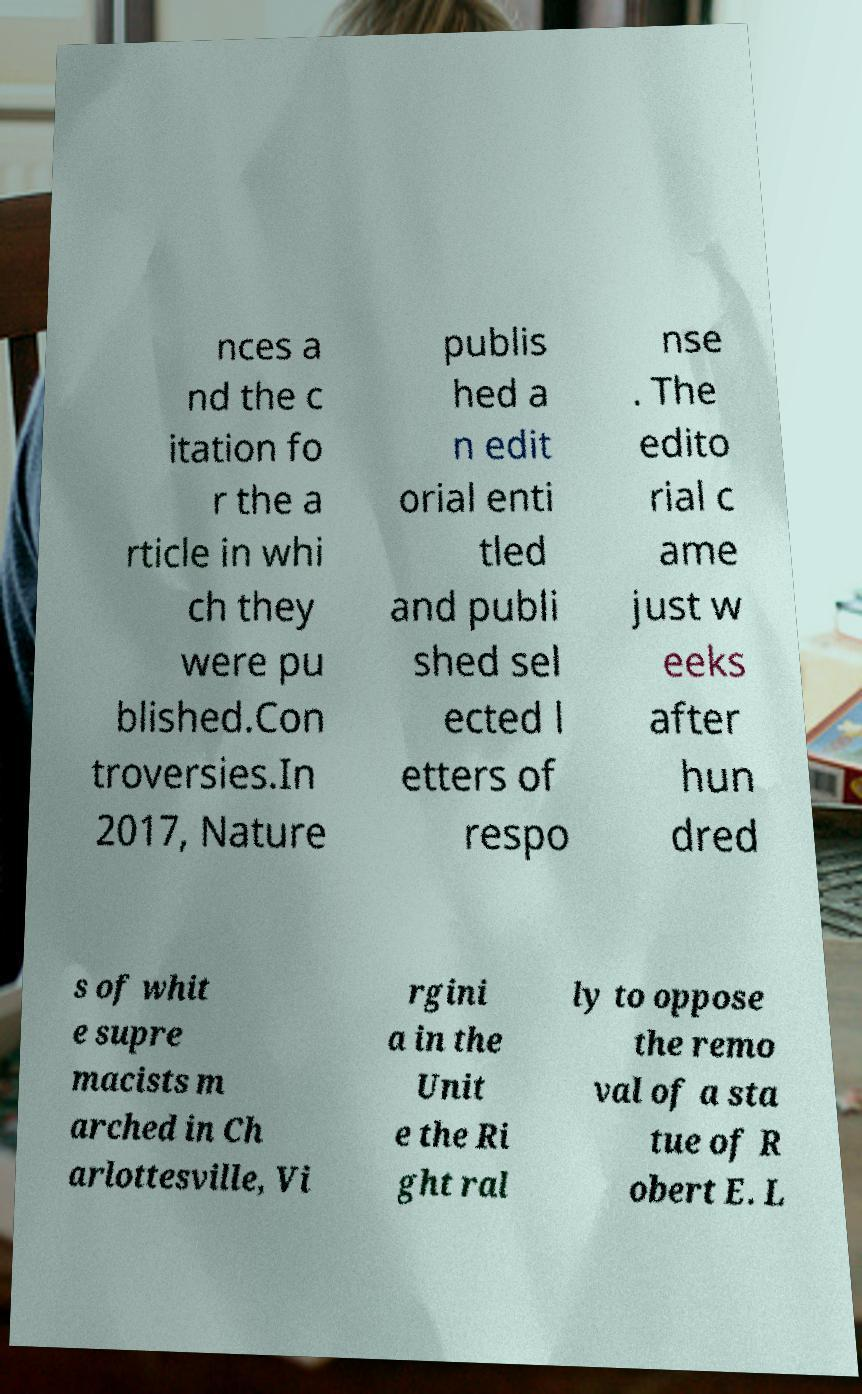There's text embedded in this image that I need extracted. Can you transcribe it verbatim? nces a nd the c itation fo r the a rticle in whi ch they were pu blished.Con troversies.In 2017, Nature publis hed a n edit orial enti tled and publi shed sel ected l etters of respo nse . The edito rial c ame just w eeks after hun dred s of whit e supre macists m arched in Ch arlottesville, Vi rgini a in the Unit e the Ri ght ral ly to oppose the remo val of a sta tue of R obert E. L 